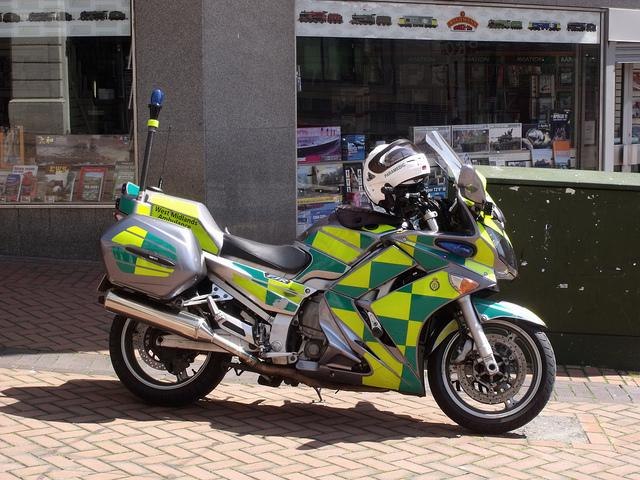The markings on the fairings of the motorcycle indicate that it belongs to which type of public organization?

Choices:
A) fire department
B) public health
C) public works
D) police public health 